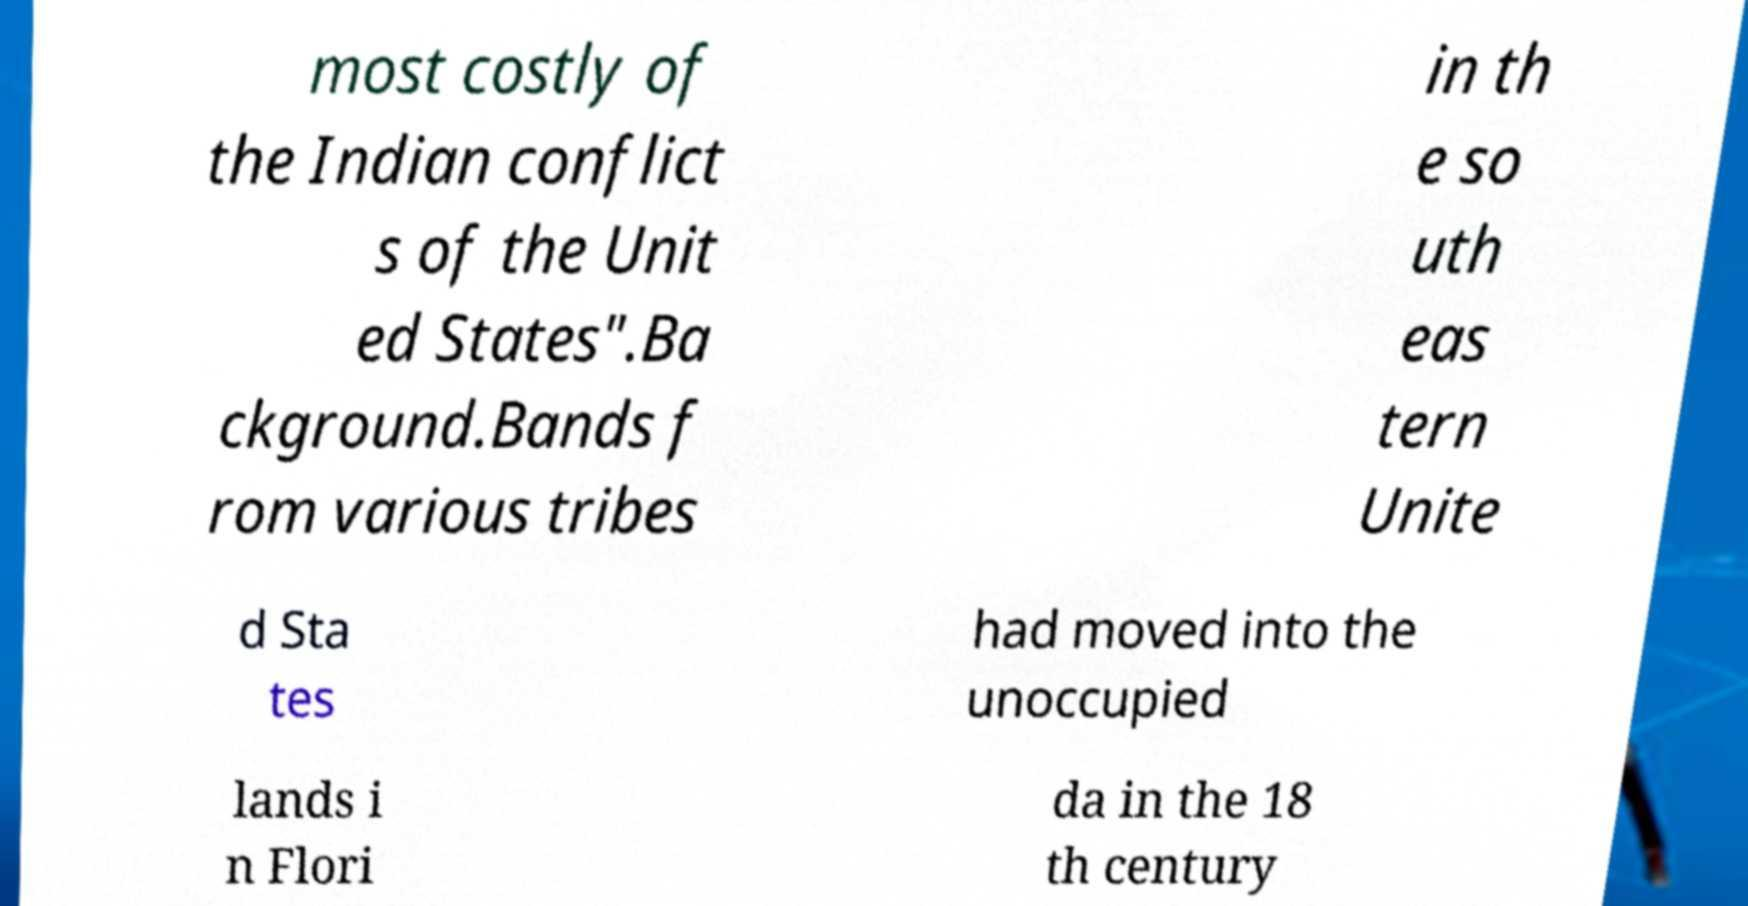For documentation purposes, I need the text within this image transcribed. Could you provide that? most costly of the Indian conflict s of the Unit ed States".Ba ckground.Bands f rom various tribes in th e so uth eas tern Unite d Sta tes had moved into the unoccupied lands i n Flori da in the 18 th century 